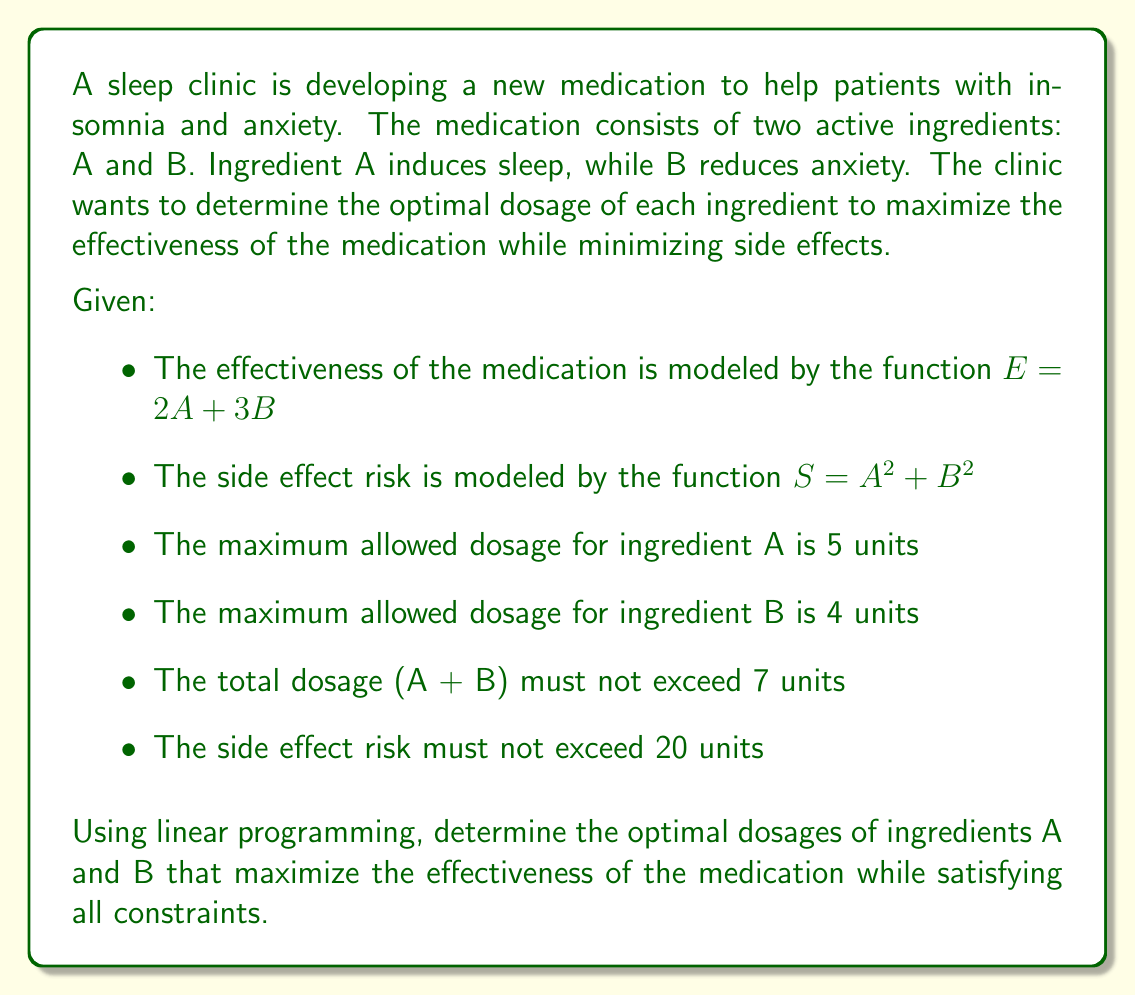Can you answer this question? To solve this problem using linear programming, we need to formulate the objective function and constraints, then solve the resulting system.

1. Objective function:
   Maximize $E = 2A + 3B$

2. Constraints:
   a) $A \leq 5$ (maximum dosage for A)
   b) $B \leq 4$ (maximum dosage for B)
   c) $A + B \leq 7$ (total dosage limit)
   d) $A^2 + B^2 \leq 20$ (side effect risk limit)
   e) $A \geq 0, B \geq 0$ (non-negativity constraints)

3. Linearize the non-linear constraint:
   The constraint $A^2 + B^2 \leq 20$ is non-linear. We can approximate it by inscribing a regular octagon within the circle defined by this equation. The octagon's edges can be represented by linear inequalities:

   $A + B \leq \sqrt{20}$
   $A - B \leq \sqrt{20}$
   $-A + B \leq \sqrt{20}$
   $-A - B \leq \sqrt{20}$

4. Solve the linear programming problem:
   Maximize $E = 2A + 3B$
   Subject to:
   $A \leq 5$
   $B \leq 4$
   $A + B \leq 7$
   $A + B \leq \sqrt{20}$
   $A - B \leq \sqrt{20}$
   $-A + B \leq \sqrt{20}$
   $-A - B \leq \sqrt{20}$
   $A \geq 0, B \geq 0$

5. Using a linear programming solver or graphical method, we find the optimal solution:
   $A = 3.162$ (approximately $\sqrt{10}$)
   $B = 3.162$ (approximately $\sqrt{10}$)

6. Verify the constraints:
   - $3.162 \leq 5$ and $3.162 \leq 4$ (satisfied)
   - $3.162 + 3.162 = 6.324 \leq 7$ (satisfied)
   - $3.162^2 + 3.162^2 = 20$ (satisfied)

7. Calculate the maximum effectiveness:
   $E = 2(3.162) + 3(3.162) = 15.81$
Answer: The optimal dosages are approximately $A = \sqrt{10} \approx 3.162$ units and $B = \sqrt{10} \approx 3.162$ units, resulting in a maximum effectiveness of $E = 15.81$. 